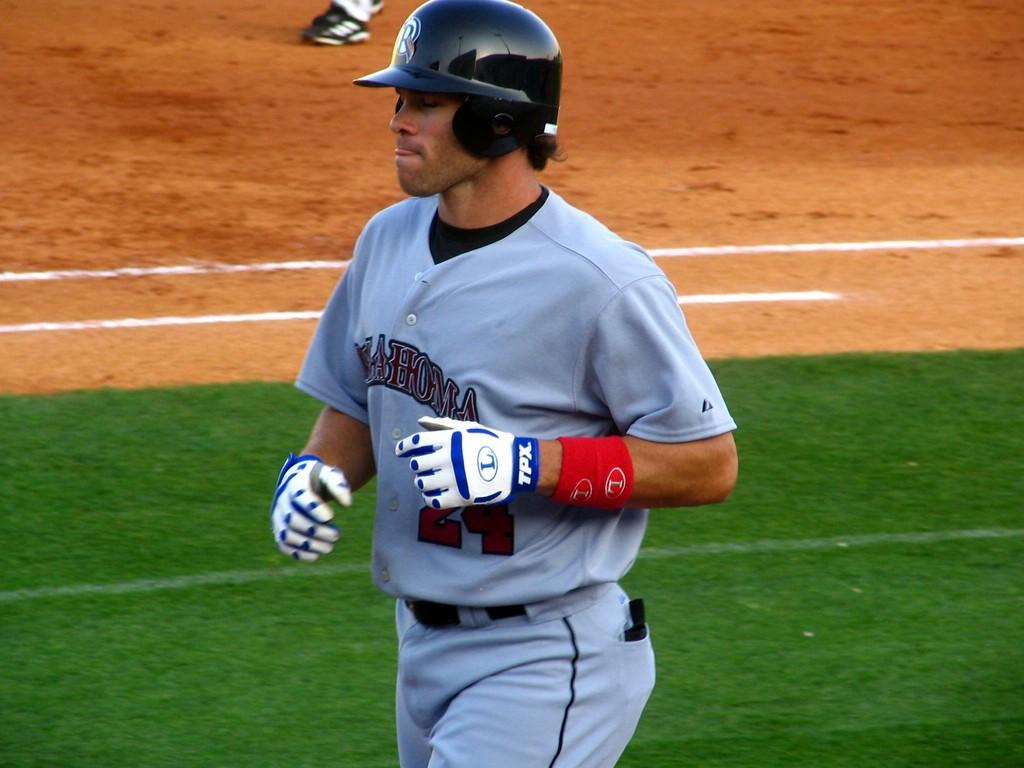Who is present in the image? There is a man in the image. What protective gear is the man wearing? The man is wearing a helmet and gloves. What surface is the man standing on? The man is standing on the ground. What type of stew is the man preparing in the image? There is no stew present in the image, and the man is not shown preparing any food. 